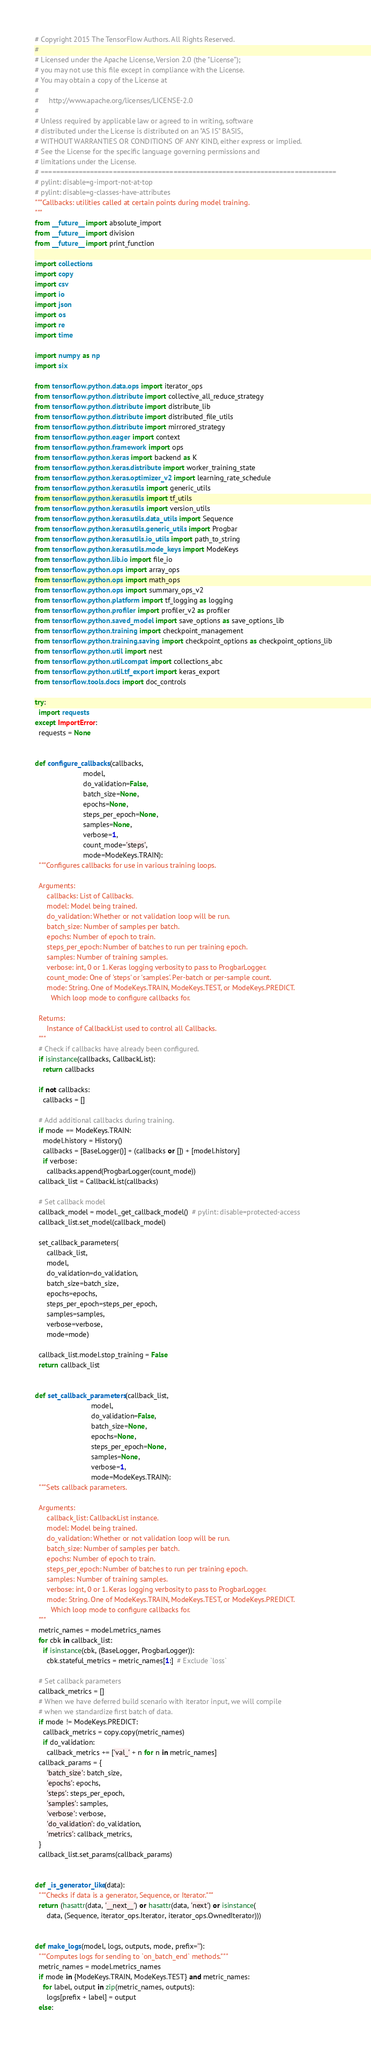Convert code to text. <code><loc_0><loc_0><loc_500><loc_500><_Python_># Copyright 2015 The TensorFlow Authors. All Rights Reserved.
#
# Licensed under the Apache License, Version 2.0 (the "License");
# you may not use this file except in compliance with the License.
# You may obtain a copy of the License at
#
#     http://www.apache.org/licenses/LICENSE-2.0
#
# Unless required by applicable law or agreed to in writing, software
# distributed under the License is distributed on an "AS IS" BASIS,
# WITHOUT WARRANTIES OR CONDITIONS OF ANY KIND, either express or implied.
# See the License for the specific language governing permissions and
# limitations under the License.
# ==============================================================================
# pylint: disable=g-import-not-at-top
# pylint: disable=g-classes-have-attributes
"""Callbacks: utilities called at certain points during model training.
"""
from __future__ import absolute_import
from __future__ import division
from __future__ import print_function

import collections
import copy
import csv
import io
import json
import os
import re
import time

import numpy as np
import six

from tensorflow.python.data.ops import iterator_ops
from tensorflow.python.distribute import collective_all_reduce_strategy
from tensorflow.python.distribute import distribute_lib
from tensorflow.python.distribute import distributed_file_utils
from tensorflow.python.distribute import mirrored_strategy
from tensorflow.python.eager import context
from tensorflow.python.framework import ops
from tensorflow.python.keras import backend as K
from tensorflow.python.keras.distribute import worker_training_state
from tensorflow.python.keras.optimizer_v2 import learning_rate_schedule
from tensorflow.python.keras.utils import generic_utils
from tensorflow.python.keras.utils import tf_utils
from tensorflow.python.keras.utils import version_utils
from tensorflow.python.keras.utils.data_utils import Sequence
from tensorflow.python.keras.utils.generic_utils import Progbar
from tensorflow.python.keras.utils.io_utils import path_to_string
from tensorflow.python.keras.utils.mode_keys import ModeKeys
from tensorflow.python.lib.io import file_io
from tensorflow.python.ops import array_ops
from tensorflow.python.ops import math_ops
from tensorflow.python.ops import summary_ops_v2
from tensorflow.python.platform import tf_logging as logging
from tensorflow.python.profiler import profiler_v2 as profiler
from tensorflow.python.saved_model import save_options as save_options_lib
from tensorflow.python.training import checkpoint_management
from tensorflow.python.training.saving import checkpoint_options as checkpoint_options_lib
from tensorflow.python.util import nest
from tensorflow.python.util.compat import collections_abc
from tensorflow.python.util.tf_export import keras_export
from tensorflow.tools.docs import doc_controls

try:
  import requests
except ImportError:
  requests = None


def configure_callbacks(callbacks,
                        model,
                        do_validation=False,
                        batch_size=None,
                        epochs=None,
                        steps_per_epoch=None,
                        samples=None,
                        verbose=1,
                        count_mode='steps',
                        mode=ModeKeys.TRAIN):
  """Configures callbacks for use in various training loops.

  Arguments:
      callbacks: List of Callbacks.
      model: Model being trained.
      do_validation: Whether or not validation loop will be run.
      batch_size: Number of samples per batch.
      epochs: Number of epoch to train.
      steps_per_epoch: Number of batches to run per training epoch.
      samples: Number of training samples.
      verbose: int, 0 or 1. Keras logging verbosity to pass to ProgbarLogger.
      count_mode: One of 'steps' or 'samples'. Per-batch or per-sample count.
      mode: String. One of ModeKeys.TRAIN, ModeKeys.TEST, or ModeKeys.PREDICT.
        Which loop mode to configure callbacks for.

  Returns:
      Instance of CallbackList used to control all Callbacks.
  """
  # Check if callbacks have already been configured.
  if isinstance(callbacks, CallbackList):
    return callbacks

  if not callbacks:
    callbacks = []

  # Add additional callbacks during training.
  if mode == ModeKeys.TRAIN:
    model.history = History()
    callbacks = [BaseLogger()] + (callbacks or []) + [model.history]
    if verbose:
      callbacks.append(ProgbarLogger(count_mode))
  callback_list = CallbackList(callbacks)

  # Set callback model
  callback_model = model._get_callback_model()  # pylint: disable=protected-access
  callback_list.set_model(callback_model)

  set_callback_parameters(
      callback_list,
      model,
      do_validation=do_validation,
      batch_size=batch_size,
      epochs=epochs,
      steps_per_epoch=steps_per_epoch,
      samples=samples,
      verbose=verbose,
      mode=mode)

  callback_list.model.stop_training = False
  return callback_list


def set_callback_parameters(callback_list,
                            model,
                            do_validation=False,
                            batch_size=None,
                            epochs=None,
                            steps_per_epoch=None,
                            samples=None,
                            verbose=1,
                            mode=ModeKeys.TRAIN):
  """Sets callback parameters.

  Arguments:
      callback_list: CallbackList instance.
      model: Model being trained.
      do_validation: Whether or not validation loop will be run.
      batch_size: Number of samples per batch.
      epochs: Number of epoch to train.
      steps_per_epoch: Number of batches to run per training epoch.
      samples: Number of training samples.
      verbose: int, 0 or 1. Keras logging verbosity to pass to ProgbarLogger.
      mode: String. One of ModeKeys.TRAIN, ModeKeys.TEST, or ModeKeys.PREDICT.
        Which loop mode to configure callbacks for.
  """
  metric_names = model.metrics_names
  for cbk in callback_list:
    if isinstance(cbk, (BaseLogger, ProgbarLogger)):
      cbk.stateful_metrics = metric_names[1:]  # Exclude `loss`

  # Set callback parameters
  callback_metrics = []
  # When we have deferred build scenario with iterator input, we will compile
  # when we standardize first batch of data.
  if mode != ModeKeys.PREDICT:
    callback_metrics = copy.copy(metric_names)
    if do_validation:
      callback_metrics += ['val_' + n for n in metric_names]
  callback_params = {
      'batch_size': batch_size,
      'epochs': epochs,
      'steps': steps_per_epoch,
      'samples': samples,
      'verbose': verbose,
      'do_validation': do_validation,
      'metrics': callback_metrics,
  }
  callback_list.set_params(callback_params)


def _is_generator_like(data):
  """Checks if data is a generator, Sequence, or Iterator."""
  return (hasattr(data, '__next__') or hasattr(data, 'next') or isinstance(
      data, (Sequence, iterator_ops.Iterator, iterator_ops.OwnedIterator)))


def make_logs(model, logs, outputs, mode, prefix=''):
  """Computes logs for sending to `on_batch_end` methods."""
  metric_names = model.metrics_names
  if mode in {ModeKeys.TRAIN, ModeKeys.TEST} and metric_names:
    for label, output in zip(metric_names, outputs):
      logs[prefix + label] = output
  else:</code> 